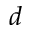Convert formula to latex. <formula><loc_0><loc_0><loc_500><loc_500>d</formula> 